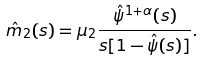<formula> <loc_0><loc_0><loc_500><loc_500>\hat { m } _ { 2 } ( s ) = \mu _ { 2 } \frac { \hat { \psi } ^ { 1 + \alpha } ( s ) } { s [ 1 - \hat { \psi } ( s ) ] } .</formula> 